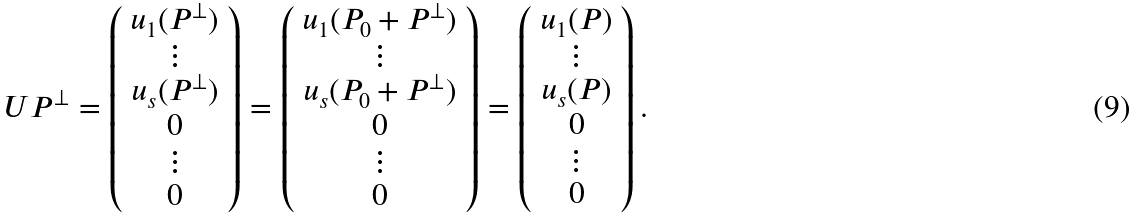<formula> <loc_0><loc_0><loc_500><loc_500>U P ^ { \perp } = \left ( \begin{array} { c } u _ { 1 } ( P ^ { \perp } ) \\ \vdots \\ u _ { s } ( P ^ { \perp } ) \\ 0 \\ \vdots \\ 0 \end{array} \right ) = \left ( \begin{array} { c } u _ { 1 } ( P _ { 0 } + P ^ { \perp } ) \\ \vdots \\ u _ { s } ( P _ { 0 } + P ^ { \perp } ) \\ 0 \\ \vdots \\ 0 \end{array} \right ) = \left ( \begin{array} { c } u _ { 1 } ( P ) \\ \vdots \\ u _ { s } ( P ) \\ 0 \\ \vdots \\ 0 \end{array} \right ) .</formula> 